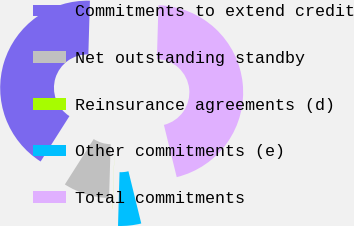Convert chart. <chart><loc_0><loc_0><loc_500><loc_500><pie_chart><fcel>Commitments to extend credit<fcel>Net outstanding standby<fcel>Reinsurance agreements (d)<fcel>Other commitments (e)<fcel>Total commitments<nl><fcel>41.45%<fcel>8.54%<fcel>0.02%<fcel>4.28%<fcel>45.71%<nl></chart> 